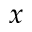Convert formula to latex. <formula><loc_0><loc_0><loc_500><loc_500>x</formula> 